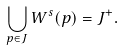Convert formula to latex. <formula><loc_0><loc_0><loc_500><loc_500>\bigcup _ { p \in J } W ^ { s } ( p ) = J ^ { + } .</formula> 